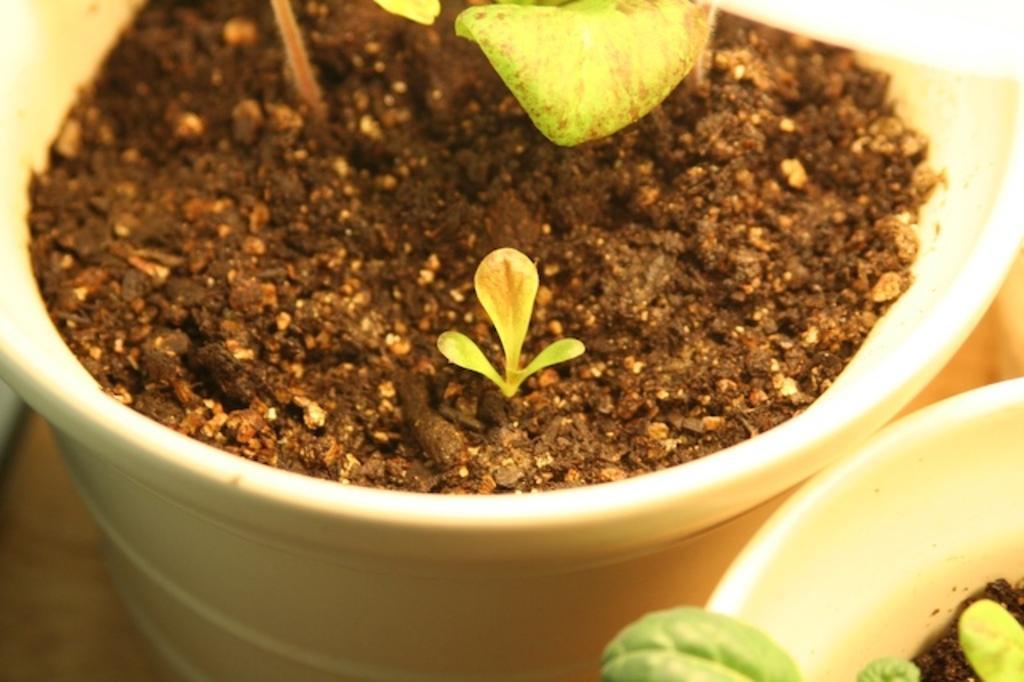Please provide a concise description of this image. In this image we can see two pots with mud and plants on the surface which looks like a floor. There is one object on the left side of the image. 